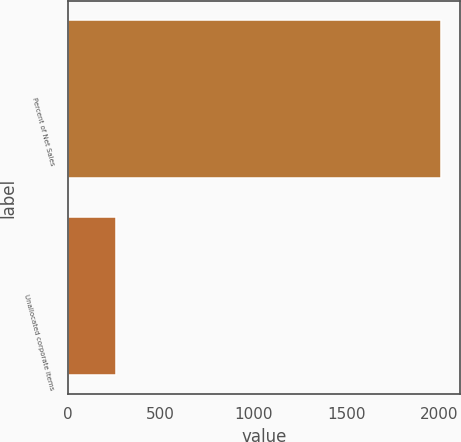Convert chart. <chart><loc_0><loc_0><loc_500><loc_500><bar_chart><fcel>Percent of Net Sales<fcel>Unallocated corporate items<nl><fcel>2014<fcel>258.4<nl></chart> 